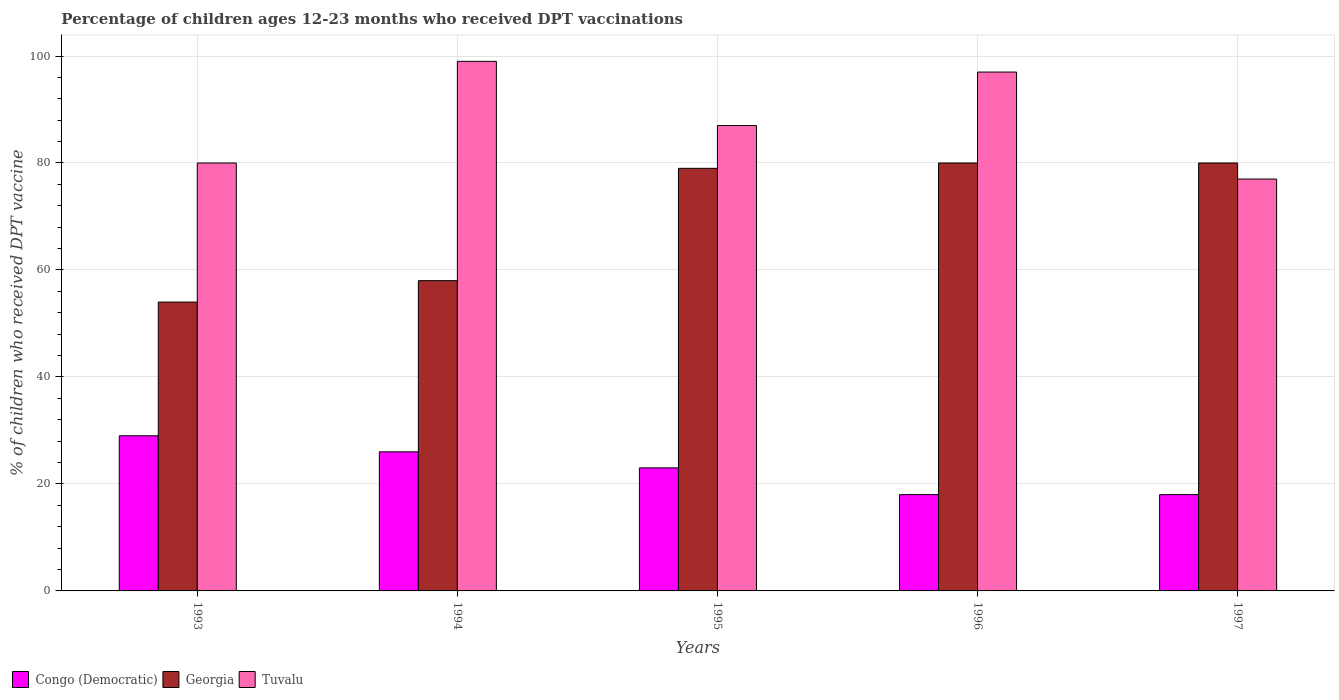How many different coloured bars are there?
Ensure brevity in your answer.  3. How many bars are there on the 2nd tick from the left?
Give a very brief answer. 3. How many bars are there on the 5th tick from the right?
Offer a terse response. 3. What is the label of the 4th group of bars from the left?
Offer a terse response. 1996. In how many cases, is the number of bars for a given year not equal to the number of legend labels?
Keep it short and to the point. 0. What is the percentage of children who received DPT vaccination in Tuvalu in 1993?
Keep it short and to the point. 80. Across all years, what is the maximum percentage of children who received DPT vaccination in Tuvalu?
Give a very brief answer. 99. In which year was the percentage of children who received DPT vaccination in Tuvalu minimum?
Your answer should be very brief. 1997. What is the total percentage of children who received DPT vaccination in Tuvalu in the graph?
Your answer should be compact. 440. What is the difference between the percentage of children who received DPT vaccination in Georgia in 1995 and that in 1997?
Provide a short and direct response. -1. What is the difference between the percentage of children who received DPT vaccination in Congo (Democratic) in 1994 and the percentage of children who received DPT vaccination in Georgia in 1995?
Provide a succinct answer. -53. What is the average percentage of children who received DPT vaccination in Georgia per year?
Make the answer very short. 70.2. In the year 1995, what is the difference between the percentage of children who received DPT vaccination in Tuvalu and percentage of children who received DPT vaccination in Congo (Democratic)?
Your response must be concise. 64. In how many years, is the percentage of children who received DPT vaccination in Tuvalu greater than 28 %?
Your answer should be compact. 5. What is the ratio of the percentage of children who received DPT vaccination in Tuvalu in 1996 to that in 1997?
Ensure brevity in your answer.  1.26. Is the percentage of children who received DPT vaccination in Tuvalu in 1994 less than that in 1996?
Your answer should be compact. No. What is the difference between the highest and the second highest percentage of children who received DPT vaccination in Congo (Democratic)?
Ensure brevity in your answer.  3. In how many years, is the percentage of children who received DPT vaccination in Georgia greater than the average percentage of children who received DPT vaccination in Georgia taken over all years?
Make the answer very short. 3. What does the 3rd bar from the left in 1994 represents?
Keep it short and to the point. Tuvalu. What does the 1st bar from the right in 1994 represents?
Your answer should be compact. Tuvalu. Is it the case that in every year, the sum of the percentage of children who received DPT vaccination in Congo (Democratic) and percentage of children who received DPT vaccination in Tuvalu is greater than the percentage of children who received DPT vaccination in Georgia?
Your answer should be compact. Yes. Are all the bars in the graph horizontal?
Keep it short and to the point. No. How many years are there in the graph?
Ensure brevity in your answer.  5. Are the values on the major ticks of Y-axis written in scientific E-notation?
Provide a succinct answer. No. Does the graph contain any zero values?
Provide a succinct answer. No. Where does the legend appear in the graph?
Ensure brevity in your answer.  Bottom left. How many legend labels are there?
Your response must be concise. 3. What is the title of the graph?
Your answer should be very brief. Percentage of children ages 12-23 months who received DPT vaccinations. Does "Sri Lanka" appear as one of the legend labels in the graph?
Give a very brief answer. No. What is the label or title of the X-axis?
Offer a very short reply. Years. What is the label or title of the Y-axis?
Provide a short and direct response. % of children who received DPT vaccine. What is the % of children who received DPT vaccine of Georgia in 1993?
Offer a terse response. 54. What is the % of children who received DPT vaccine of Georgia in 1994?
Make the answer very short. 58. What is the % of children who received DPT vaccine in Georgia in 1995?
Your answer should be very brief. 79. What is the % of children who received DPT vaccine in Congo (Democratic) in 1996?
Offer a terse response. 18. What is the % of children who received DPT vaccine in Georgia in 1996?
Your response must be concise. 80. What is the % of children who received DPT vaccine of Tuvalu in 1996?
Keep it short and to the point. 97. What is the % of children who received DPT vaccine of Tuvalu in 1997?
Make the answer very short. 77. Across all years, what is the maximum % of children who received DPT vaccine of Tuvalu?
Offer a terse response. 99. Across all years, what is the minimum % of children who received DPT vaccine of Congo (Democratic)?
Your answer should be very brief. 18. What is the total % of children who received DPT vaccine in Congo (Democratic) in the graph?
Your answer should be compact. 114. What is the total % of children who received DPT vaccine in Georgia in the graph?
Offer a very short reply. 351. What is the total % of children who received DPT vaccine in Tuvalu in the graph?
Keep it short and to the point. 440. What is the difference between the % of children who received DPT vaccine in Congo (Democratic) in 1993 and that in 1994?
Keep it short and to the point. 3. What is the difference between the % of children who received DPT vaccine in Georgia in 1993 and that in 1994?
Ensure brevity in your answer.  -4. What is the difference between the % of children who received DPT vaccine of Georgia in 1993 and that in 1995?
Offer a very short reply. -25. What is the difference between the % of children who received DPT vaccine of Georgia in 1993 and that in 1996?
Make the answer very short. -26. What is the difference between the % of children who received DPT vaccine of Georgia in 1993 and that in 1997?
Make the answer very short. -26. What is the difference between the % of children who received DPT vaccine in Tuvalu in 1993 and that in 1997?
Your answer should be compact. 3. What is the difference between the % of children who received DPT vaccine of Congo (Democratic) in 1994 and that in 1995?
Provide a succinct answer. 3. What is the difference between the % of children who received DPT vaccine in Georgia in 1994 and that in 1995?
Your response must be concise. -21. What is the difference between the % of children who received DPT vaccine of Tuvalu in 1994 and that in 1995?
Provide a short and direct response. 12. What is the difference between the % of children who received DPT vaccine in Georgia in 1994 and that in 1996?
Offer a terse response. -22. What is the difference between the % of children who received DPT vaccine of Congo (Democratic) in 1994 and that in 1997?
Offer a terse response. 8. What is the difference between the % of children who received DPT vaccine of Georgia in 1994 and that in 1997?
Give a very brief answer. -22. What is the difference between the % of children who received DPT vaccine of Tuvalu in 1994 and that in 1997?
Ensure brevity in your answer.  22. What is the difference between the % of children who received DPT vaccine in Georgia in 1995 and that in 1996?
Your answer should be very brief. -1. What is the difference between the % of children who received DPT vaccine of Tuvalu in 1995 and that in 1996?
Your answer should be very brief. -10. What is the difference between the % of children who received DPT vaccine in Georgia in 1995 and that in 1997?
Give a very brief answer. -1. What is the difference between the % of children who received DPT vaccine of Congo (Democratic) in 1996 and that in 1997?
Your response must be concise. 0. What is the difference between the % of children who received DPT vaccine of Congo (Democratic) in 1993 and the % of children who received DPT vaccine of Tuvalu in 1994?
Make the answer very short. -70. What is the difference between the % of children who received DPT vaccine of Georgia in 1993 and the % of children who received DPT vaccine of Tuvalu in 1994?
Your answer should be compact. -45. What is the difference between the % of children who received DPT vaccine of Congo (Democratic) in 1993 and the % of children who received DPT vaccine of Tuvalu in 1995?
Provide a short and direct response. -58. What is the difference between the % of children who received DPT vaccine of Georgia in 1993 and the % of children who received DPT vaccine of Tuvalu in 1995?
Your answer should be compact. -33. What is the difference between the % of children who received DPT vaccine in Congo (Democratic) in 1993 and the % of children who received DPT vaccine in Georgia in 1996?
Give a very brief answer. -51. What is the difference between the % of children who received DPT vaccine of Congo (Democratic) in 1993 and the % of children who received DPT vaccine of Tuvalu in 1996?
Your answer should be very brief. -68. What is the difference between the % of children who received DPT vaccine in Georgia in 1993 and the % of children who received DPT vaccine in Tuvalu in 1996?
Ensure brevity in your answer.  -43. What is the difference between the % of children who received DPT vaccine of Congo (Democratic) in 1993 and the % of children who received DPT vaccine of Georgia in 1997?
Ensure brevity in your answer.  -51. What is the difference between the % of children who received DPT vaccine in Congo (Democratic) in 1993 and the % of children who received DPT vaccine in Tuvalu in 1997?
Offer a very short reply. -48. What is the difference between the % of children who received DPT vaccine in Congo (Democratic) in 1994 and the % of children who received DPT vaccine in Georgia in 1995?
Ensure brevity in your answer.  -53. What is the difference between the % of children who received DPT vaccine of Congo (Democratic) in 1994 and the % of children who received DPT vaccine of Tuvalu in 1995?
Your answer should be very brief. -61. What is the difference between the % of children who received DPT vaccine of Georgia in 1994 and the % of children who received DPT vaccine of Tuvalu in 1995?
Your response must be concise. -29. What is the difference between the % of children who received DPT vaccine of Congo (Democratic) in 1994 and the % of children who received DPT vaccine of Georgia in 1996?
Provide a short and direct response. -54. What is the difference between the % of children who received DPT vaccine in Congo (Democratic) in 1994 and the % of children who received DPT vaccine in Tuvalu in 1996?
Provide a short and direct response. -71. What is the difference between the % of children who received DPT vaccine of Georgia in 1994 and the % of children who received DPT vaccine of Tuvalu in 1996?
Provide a succinct answer. -39. What is the difference between the % of children who received DPT vaccine of Congo (Democratic) in 1994 and the % of children who received DPT vaccine of Georgia in 1997?
Give a very brief answer. -54. What is the difference between the % of children who received DPT vaccine in Congo (Democratic) in 1994 and the % of children who received DPT vaccine in Tuvalu in 1997?
Give a very brief answer. -51. What is the difference between the % of children who received DPT vaccine in Georgia in 1994 and the % of children who received DPT vaccine in Tuvalu in 1997?
Make the answer very short. -19. What is the difference between the % of children who received DPT vaccine of Congo (Democratic) in 1995 and the % of children who received DPT vaccine of Georgia in 1996?
Ensure brevity in your answer.  -57. What is the difference between the % of children who received DPT vaccine of Congo (Democratic) in 1995 and the % of children who received DPT vaccine of Tuvalu in 1996?
Your answer should be compact. -74. What is the difference between the % of children who received DPT vaccine in Georgia in 1995 and the % of children who received DPT vaccine in Tuvalu in 1996?
Your response must be concise. -18. What is the difference between the % of children who received DPT vaccine in Congo (Democratic) in 1995 and the % of children who received DPT vaccine in Georgia in 1997?
Provide a succinct answer. -57. What is the difference between the % of children who received DPT vaccine of Congo (Democratic) in 1995 and the % of children who received DPT vaccine of Tuvalu in 1997?
Provide a succinct answer. -54. What is the difference between the % of children who received DPT vaccine in Congo (Democratic) in 1996 and the % of children who received DPT vaccine in Georgia in 1997?
Offer a very short reply. -62. What is the difference between the % of children who received DPT vaccine of Congo (Democratic) in 1996 and the % of children who received DPT vaccine of Tuvalu in 1997?
Offer a terse response. -59. What is the average % of children who received DPT vaccine of Congo (Democratic) per year?
Provide a succinct answer. 22.8. What is the average % of children who received DPT vaccine in Georgia per year?
Your answer should be very brief. 70.2. In the year 1993, what is the difference between the % of children who received DPT vaccine of Congo (Democratic) and % of children who received DPT vaccine of Tuvalu?
Your response must be concise. -51. In the year 1993, what is the difference between the % of children who received DPT vaccine in Georgia and % of children who received DPT vaccine in Tuvalu?
Ensure brevity in your answer.  -26. In the year 1994, what is the difference between the % of children who received DPT vaccine in Congo (Democratic) and % of children who received DPT vaccine in Georgia?
Your answer should be compact. -32. In the year 1994, what is the difference between the % of children who received DPT vaccine in Congo (Democratic) and % of children who received DPT vaccine in Tuvalu?
Offer a very short reply. -73. In the year 1994, what is the difference between the % of children who received DPT vaccine in Georgia and % of children who received DPT vaccine in Tuvalu?
Your answer should be very brief. -41. In the year 1995, what is the difference between the % of children who received DPT vaccine in Congo (Democratic) and % of children who received DPT vaccine in Georgia?
Give a very brief answer. -56. In the year 1995, what is the difference between the % of children who received DPT vaccine in Congo (Democratic) and % of children who received DPT vaccine in Tuvalu?
Provide a succinct answer. -64. In the year 1996, what is the difference between the % of children who received DPT vaccine of Congo (Democratic) and % of children who received DPT vaccine of Georgia?
Provide a succinct answer. -62. In the year 1996, what is the difference between the % of children who received DPT vaccine of Congo (Democratic) and % of children who received DPT vaccine of Tuvalu?
Ensure brevity in your answer.  -79. In the year 1997, what is the difference between the % of children who received DPT vaccine in Congo (Democratic) and % of children who received DPT vaccine in Georgia?
Keep it short and to the point. -62. In the year 1997, what is the difference between the % of children who received DPT vaccine of Congo (Democratic) and % of children who received DPT vaccine of Tuvalu?
Provide a short and direct response. -59. What is the ratio of the % of children who received DPT vaccine in Congo (Democratic) in 1993 to that in 1994?
Your response must be concise. 1.12. What is the ratio of the % of children who received DPT vaccine of Georgia in 1993 to that in 1994?
Offer a terse response. 0.93. What is the ratio of the % of children who received DPT vaccine in Tuvalu in 1993 to that in 1994?
Offer a terse response. 0.81. What is the ratio of the % of children who received DPT vaccine in Congo (Democratic) in 1993 to that in 1995?
Offer a very short reply. 1.26. What is the ratio of the % of children who received DPT vaccine of Georgia in 1993 to that in 1995?
Give a very brief answer. 0.68. What is the ratio of the % of children who received DPT vaccine in Tuvalu in 1993 to that in 1995?
Offer a very short reply. 0.92. What is the ratio of the % of children who received DPT vaccine in Congo (Democratic) in 1993 to that in 1996?
Give a very brief answer. 1.61. What is the ratio of the % of children who received DPT vaccine of Georgia in 1993 to that in 1996?
Offer a terse response. 0.68. What is the ratio of the % of children who received DPT vaccine of Tuvalu in 1993 to that in 1996?
Give a very brief answer. 0.82. What is the ratio of the % of children who received DPT vaccine of Congo (Democratic) in 1993 to that in 1997?
Your response must be concise. 1.61. What is the ratio of the % of children who received DPT vaccine of Georgia in 1993 to that in 1997?
Provide a short and direct response. 0.68. What is the ratio of the % of children who received DPT vaccine of Tuvalu in 1993 to that in 1997?
Provide a succinct answer. 1.04. What is the ratio of the % of children who received DPT vaccine of Congo (Democratic) in 1994 to that in 1995?
Keep it short and to the point. 1.13. What is the ratio of the % of children who received DPT vaccine in Georgia in 1994 to that in 1995?
Offer a terse response. 0.73. What is the ratio of the % of children who received DPT vaccine in Tuvalu in 1994 to that in 1995?
Make the answer very short. 1.14. What is the ratio of the % of children who received DPT vaccine of Congo (Democratic) in 1994 to that in 1996?
Your response must be concise. 1.44. What is the ratio of the % of children who received DPT vaccine in Georgia in 1994 to that in 1996?
Your answer should be very brief. 0.72. What is the ratio of the % of children who received DPT vaccine in Tuvalu in 1994 to that in 1996?
Offer a very short reply. 1.02. What is the ratio of the % of children who received DPT vaccine of Congo (Democratic) in 1994 to that in 1997?
Offer a terse response. 1.44. What is the ratio of the % of children who received DPT vaccine in Georgia in 1994 to that in 1997?
Your answer should be compact. 0.72. What is the ratio of the % of children who received DPT vaccine of Congo (Democratic) in 1995 to that in 1996?
Your answer should be very brief. 1.28. What is the ratio of the % of children who received DPT vaccine in Georgia in 1995 to that in 1996?
Offer a terse response. 0.99. What is the ratio of the % of children who received DPT vaccine in Tuvalu in 1995 to that in 1996?
Provide a succinct answer. 0.9. What is the ratio of the % of children who received DPT vaccine in Congo (Democratic) in 1995 to that in 1997?
Make the answer very short. 1.28. What is the ratio of the % of children who received DPT vaccine of Georgia in 1995 to that in 1997?
Your answer should be very brief. 0.99. What is the ratio of the % of children who received DPT vaccine in Tuvalu in 1995 to that in 1997?
Make the answer very short. 1.13. What is the ratio of the % of children who received DPT vaccine in Tuvalu in 1996 to that in 1997?
Provide a short and direct response. 1.26. What is the difference between the highest and the second highest % of children who received DPT vaccine of Congo (Democratic)?
Offer a very short reply. 3. What is the difference between the highest and the second highest % of children who received DPT vaccine in Georgia?
Ensure brevity in your answer.  0. What is the difference between the highest and the second highest % of children who received DPT vaccine of Tuvalu?
Your response must be concise. 2. What is the difference between the highest and the lowest % of children who received DPT vaccine in Georgia?
Offer a very short reply. 26. What is the difference between the highest and the lowest % of children who received DPT vaccine in Tuvalu?
Provide a short and direct response. 22. 